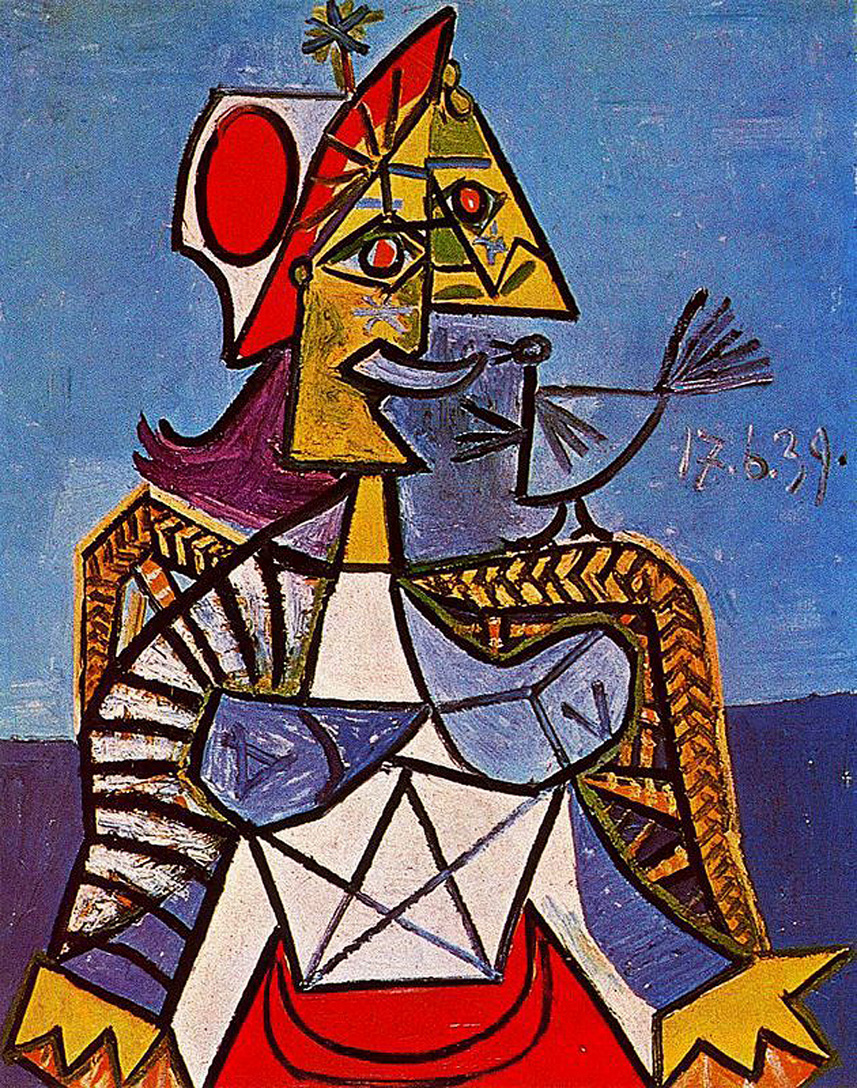Can you describe the emotions conveyed by the colors and forms used in this picture? The colors and forms in this image evoke a range of emotions. The bold, vibrant yellows and reds impart a sense of energy and vitality, perhaps reflecting the strength and power associated with the crowned figure. The contrasting deep blue background introduces a sense of calm and depth, balancing the intensity of the foreground colors. The geometric forms and sharp lines contribute to a feeling of order and structure, yet their dynamic arrangement suggests movement and liveliness. This interplay of emotions – vitality, power, calmness, and dynamism – creates a complex emotional landscape within the artwork, inviting viewers to reflect on the dualities present in the piece. 